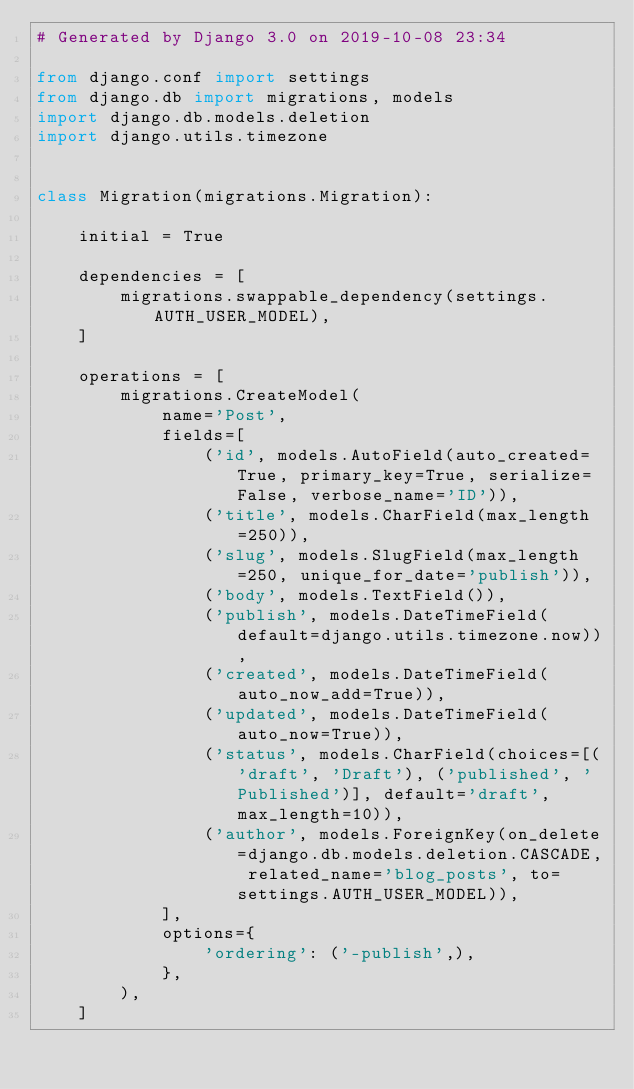Convert code to text. <code><loc_0><loc_0><loc_500><loc_500><_Python_># Generated by Django 3.0 on 2019-10-08 23:34

from django.conf import settings
from django.db import migrations, models
import django.db.models.deletion
import django.utils.timezone


class Migration(migrations.Migration):

    initial = True

    dependencies = [
        migrations.swappable_dependency(settings.AUTH_USER_MODEL),
    ]

    operations = [
        migrations.CreateModel(
            name='Post',
            fields=[
                ('id', models.AutoField(auto_created=True, primary_key=True, serialize=False, verbose_name='ID')),
                ('title', models.CharField(max_length=250)),
                ('slug', models.SlugField(max_length=250, unique_for_date='publish')),
                ('body', models.TextField()),
                ('publish', models.DateTimeField(default=django.utils.timezone.now)),
                ('created', models.DateTimeField(auto_now_add=True)),
                ('updated', models.DateTimeField(auto_now=True)),
                ('status', models.CharField(choices=[('draft', 'Draft'), ('published', 'Published')], default='draft', max_length=10)),
                ('author', models.ForeignKey(on_delete=django.db.models.deletion.CASCADE, related_name='blog_posts', to=settings.AUTH_USER_MODEL)),
            ],
            options={
                'ordering': ('-publish',),
            },
        ),
    ]
</code> 